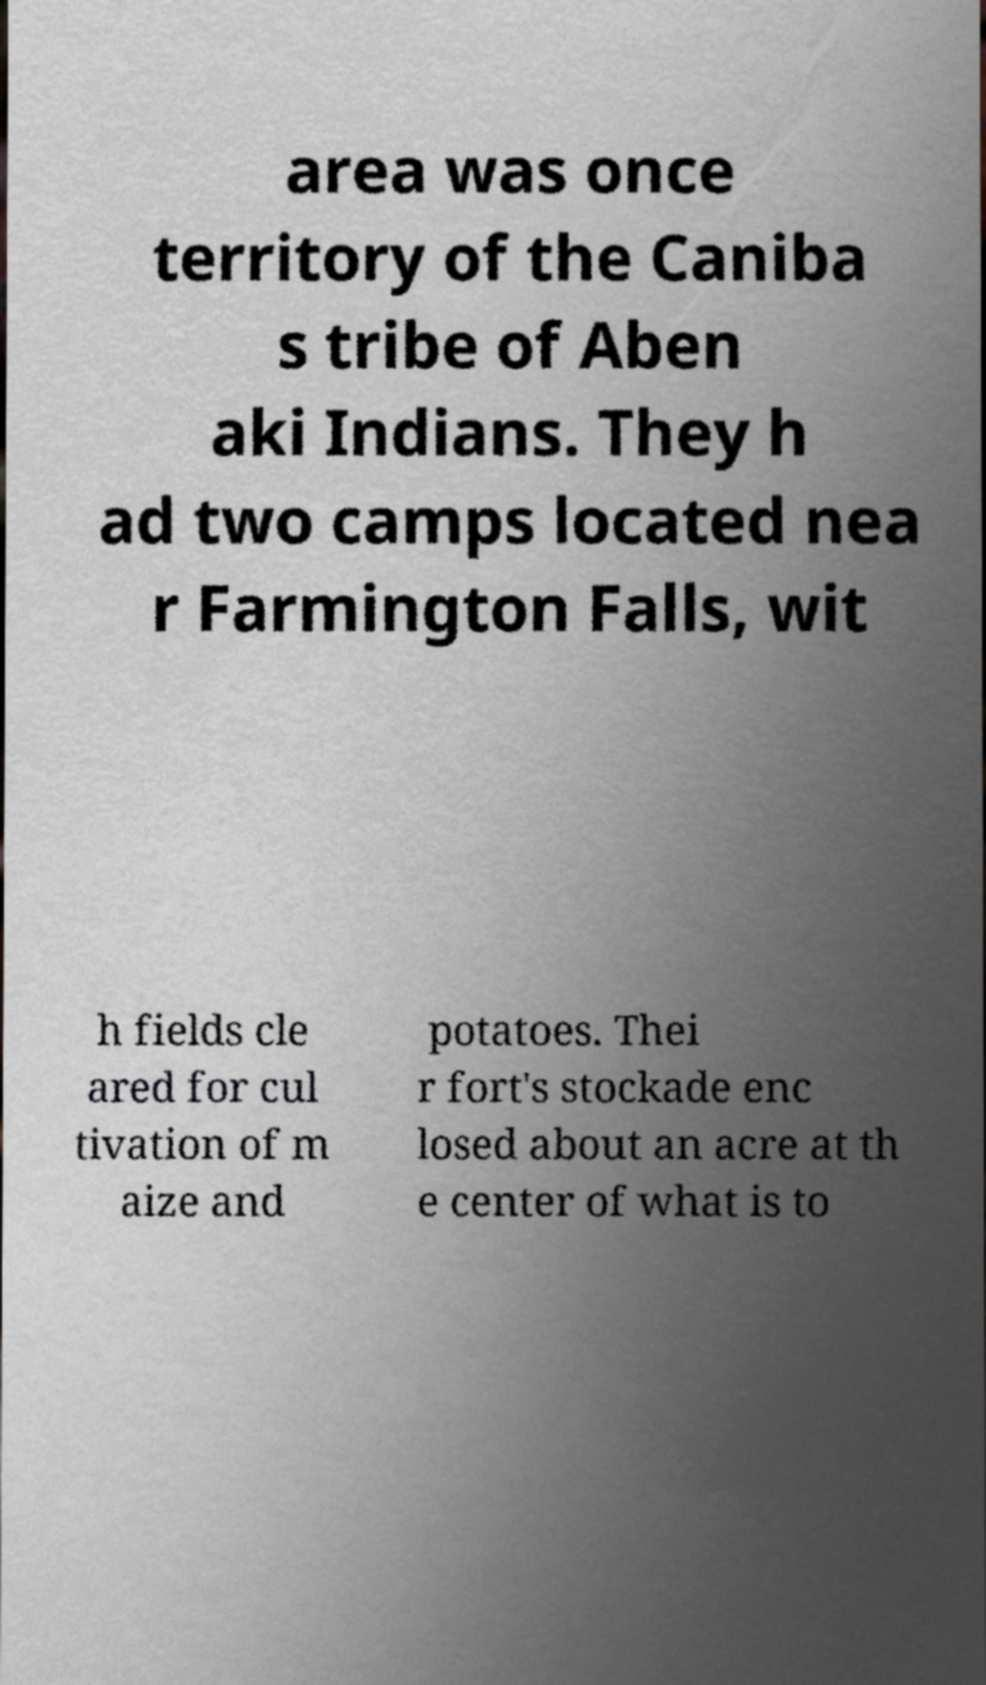I need the written content from this picture converted into text. Can you do that? area was once territory of the Caniba s tribe of Aben aki Indians. They h ad two camps located nea r Farmington Falls, wit h fields cle ared for cul tivation of m aize and potatoes. Thei r fort's stockade enc losed about an acre at th e center of what is to 